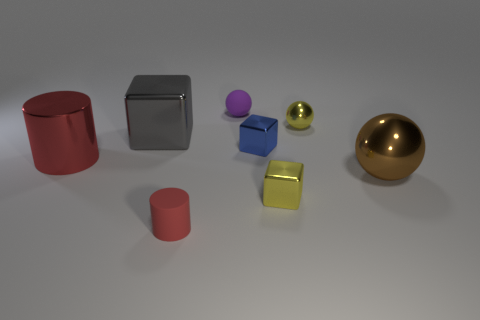Does the small rubber object in front of the large gray object have the same shape as the big object right of the purple thing?
Keep it short and to the point. No. There is a gray object that is the same shape as the blue object; what material is it?
Offer a very short reply. Metal. How many cylinders are purple matte objects or tiny rubber objects?
Provide a short and direct response. 1. How many balls are made of the same material as the small red object?
Provide a short and direct response. 1. Does the cube that is in front of the large sphere have the same material as the cylinder on the right side of the large metallic block?
Give a very brief answer. No. There is a large shiny ball that is behind the small block that is in front of the large red cylinder; how many cylinders are right of it?
Your answer should be compact. 0. There is a block that is in front of the red metallic object; does it have the same color as the shiny sphere behind the large gray metallic object?
Offer a terse response. Yes. Is there any other thing that has the same color as the big block?
Give a very brief answer. No. The small matte thing that is behind the metallic block on the right side of the tiny blue metallic object is what color?
Give a very brief answer. Purple. Is there a big cyan matte cylinder?
Give a very brief answer. No. 